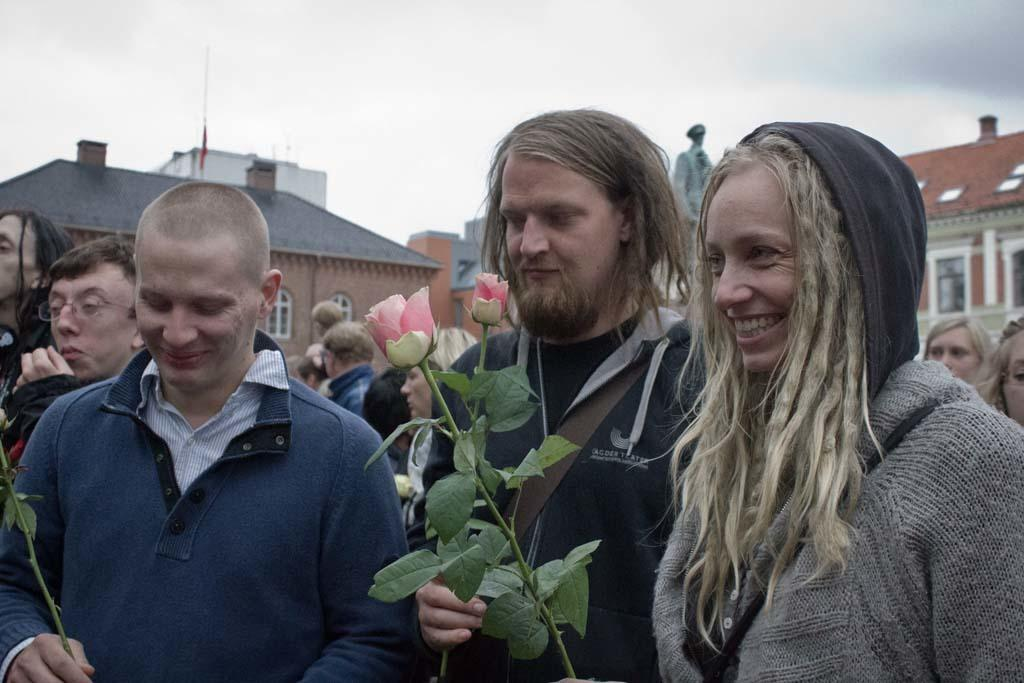How many people are in the image? There are people in the image, but the exact number is not specified. What are two of the people holding? Two persons are holding roses in the image. What can be seen in the background of the image? There are houses and a statue in the background of the image. How would you describe the sky in the image? The sky is cloudy in the image. What breed of dog can be seen playing with trucks in the image? There is no dog or trucks present in the image; it features people holding roses and a background with houses and a statue. 